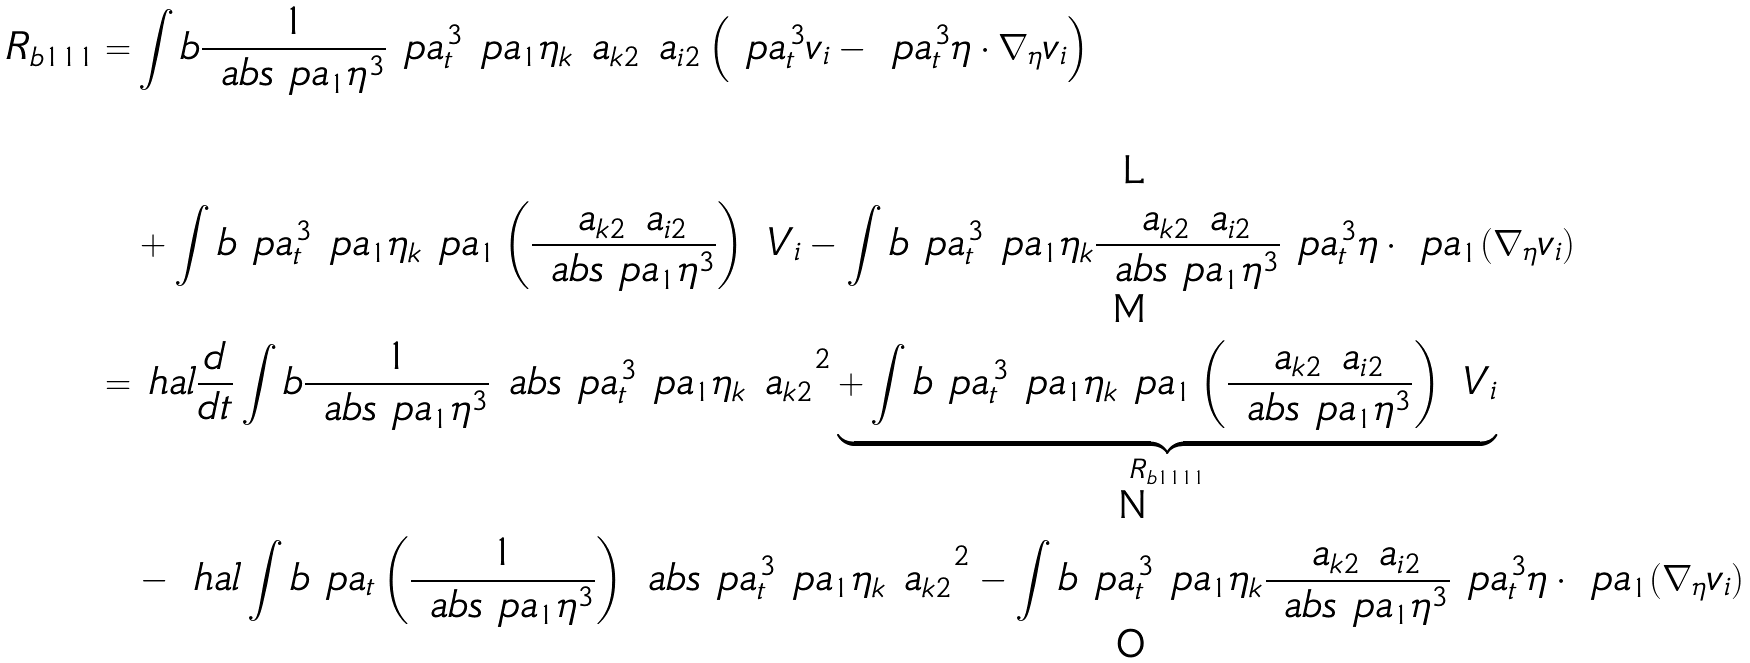<formula> <loc_0><loc_0><loc_500><loc_500>R _ { b 1 1 1 } = & \int b \frac { 1 } { \ a b s { \ p a _ { 1 } \eta } ^ { 3 } } \ p a _ { t } ^ { 3 } \ p a _ { 1 } \eta _ { k } \ a _ { k 2 } \ a _ { i 2 } \left ( \ p a _ { t } ^ { 3 } v _ { i } - \ p a _ { t } ^ { 3 } \eta \cdot \nabla _ { \eta } v _ { i } \right ) \\ & + \int b \ p a _ { t } ^ { 3 } \ p a _ { 1 } \eta _ { k } \ p a _ { 1 } \left ( \frac { \ a _ { k 2 } \ a _ { i 2 } } { \ a b s { \ p a _ { 1 } \eta } ^ { 3 } } \right ) \ V _ { i } - \int b \ p a _ { t } ^ { 3 } \ p a _ { 1 } \eta _ { k } \frac { \ a _ { k 2 } \ a _ { i 2 } } { \ a b s { \ p a _ { 1 } \eta } ^ { 3 } } \ p a _ { t } ^ { 3 } \eta \cdot \ p a _ { 1 } ( \nabla _ { \eta } v _ { i } ) \\ = & \ h a l \frac { d } { d t } \int b \frac { 1 } { \ a b s { \ p a _ { 1 } \eta } ^ { 3 } } \ a b s { \ p a _ { t } ^ { 3 } \ p a _ { 1 } \eta _ { k } \ a _ { k 2 } } ^ { 2 } \underbrace { + \int b \ p a _ { t } ^ { 3 } \ p a _ { 1 } \eta _ { k } \ p a _ { 1 } \left ( \frac { \ a _ { k 2 } \ a _ { i 2 } } { \ a b s { \ p a _ { 1 } \eta } ^ { 3 } } \right ) \ V _ { i } } _ { R _ { b 1 1 1 1 } } \\ & - \ h a l \int b \ p a _ { t } \left ( \frac { 1 } { \ a b s { \ p a _ { 1 } \eta } ^ { 3 } } \right ) \ a b s { \ p a _ { t } ^ { 3 } \ p a _ { 1 } \eta _ { k } \ a _ { k 2 } } ^ { 2 } - \int b \ p a _ { t } ^ { 3 } \ p a _ { 1 } \eta _ { k } \frac { \ a _ { k 2 } \ a _ { i 2 } } { \ a b s { \ p a _ { 1 } \eta } ^ { 3 } } \ p a _ { t } ^ { 3 } \eta \cdot \ p a _ { 1 } ( \nabla _ { \eta } v _ { i } )</formula> 